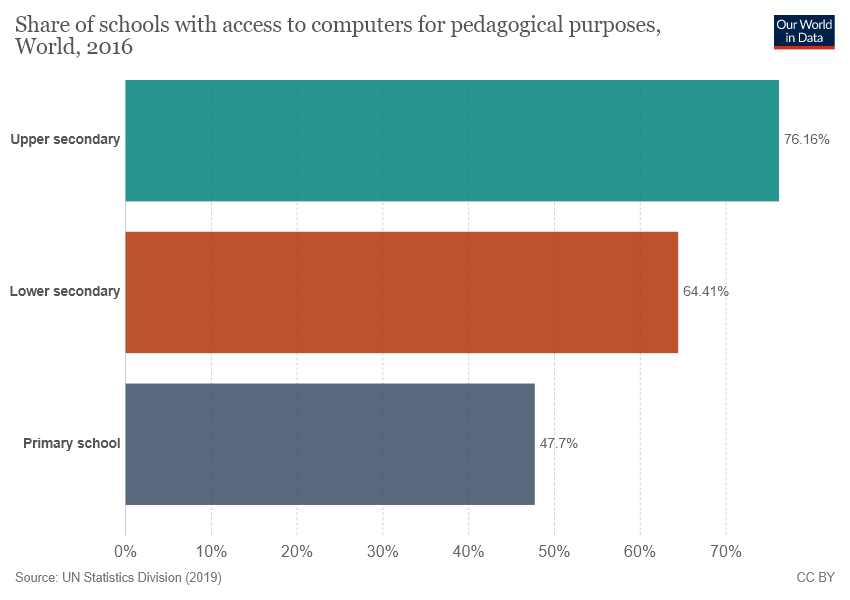Specify some key components in this picture. According to the data, only 0.477..% of primary schools have access to computers for pedagogical purposes. The median is the middle value of a dataset when it is arranged in order. To determine the median of a dataset, the dataset is typically split into two parts, with the middle value being the median. To find the median of the bar values, the bar values would be separated into two parts and the middle value would be the median. 